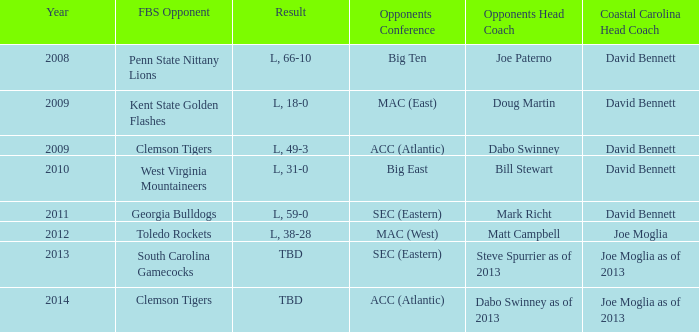How many head coaches did Kent state golden flashes have? 1.0. 